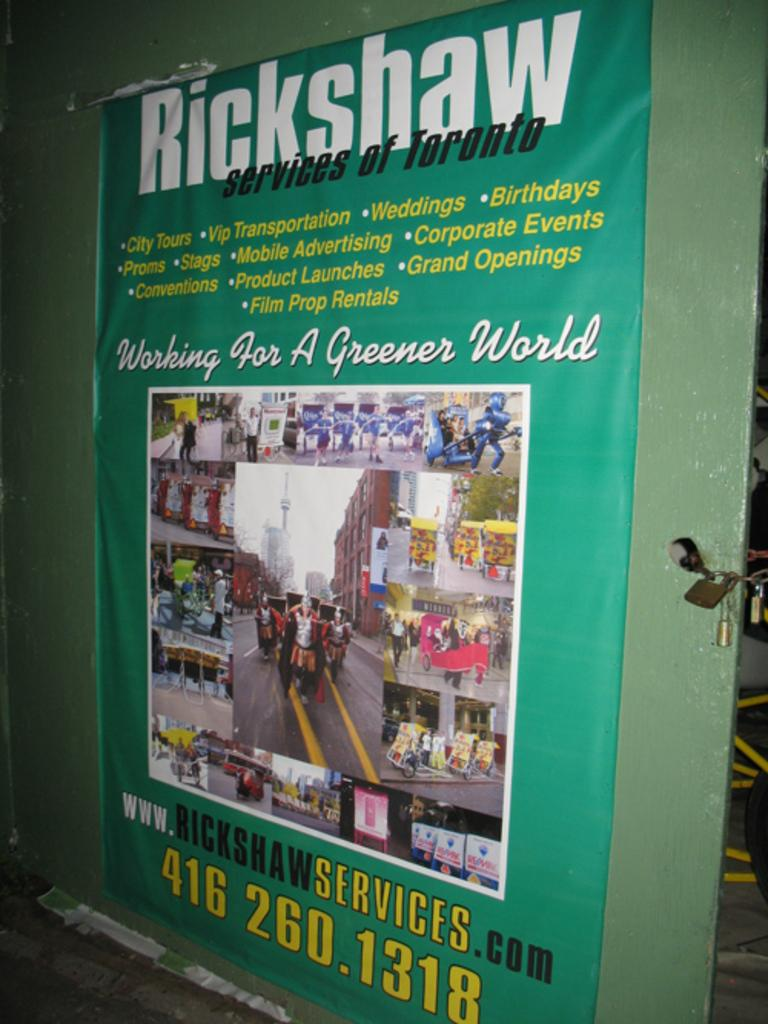<image>
Share a concise interpretation of the image provided. a sign that has the word rickshaw at the top 